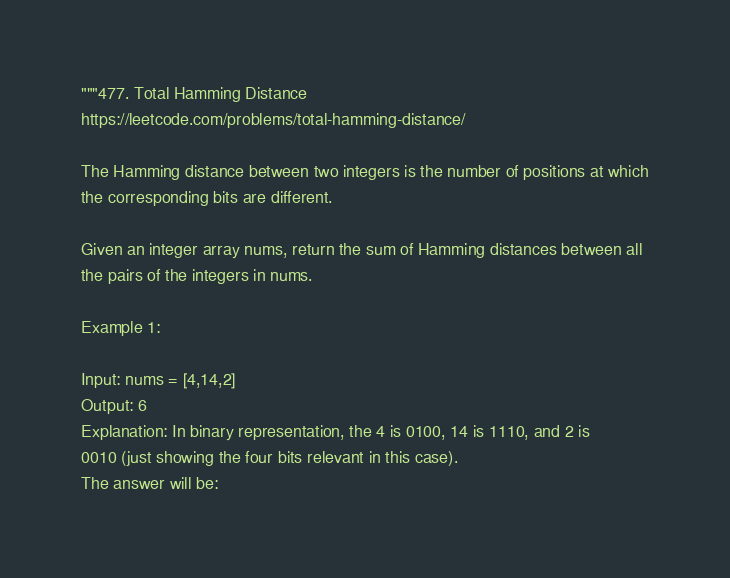<code> <loc_0><loc_0><loc_500><loc_500><_Python_>"""477. Total Hamming Distance
https://leetcode.com/problems/total-hamming-distance/

The Hamming distance between two integers is the number of positions at which
the corresponding bits are different.

Given an integer array nums, return the sum of Hamming distances between all
the pairs of the integers in nums.

Example 1:

Input: nums = [4,14,2]
Output: 6
Explanation: In binary representation, the 4 is 0100, 14 is 1110, and 2 is
0010 (just showing the four bits relevant in this case).
The answer will be:</code> 